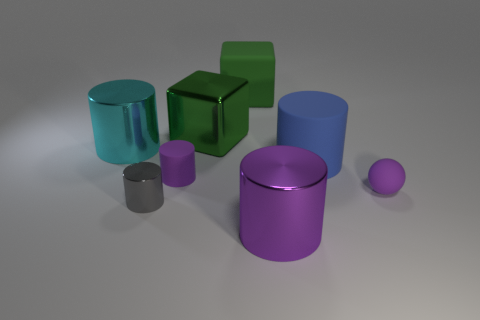Does the metallic object to the left of the tiny gray object have the same shape as the green rubber thing?
Provide a succinct answer. No. What number of big metallic things are on the left side of the tiny metallic cylinder and behind the large cyan metal cylinder?
Offer a very short reply. 0. There is a small object on the right side of the matte cylinder left of the cylinder in front of the gray thing; what is its color?
Offer a terse response. Purple. How many purple rubber spheres are right of the big metal cylinder in front of the tiny ball?
Keep it short and to the point. 1. What number of other objects are there of the same shape as the large cyan thing?
Keep it short and to the point. 4. How many objects are either large shiny objects or large things on the right side of the tiny metal cylinder?
Provide a short and direct response. 5. Are there more large rubber things that are behind the big green rubber block than blue cylinders behind the big green metallic cube?
Your response must be concise. No. There is a tiny thing behind the small purple rubber thing that is to the right of the big metal cylinder that is right of the big cyan shiny cylinder; what is its shape?
Give a very brief answer. Cylinder. What shape is the big object that is in front of the purple rubber thing that is on the left side of the big green shiny block?
Offer a very short reply. Cylinder. Are there any small blue things made of the same material as the large cyan cylinder?
Give a very brief answer. No. 